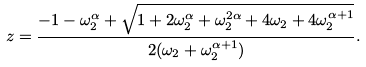Convert formula to latex. <formula><loc_0><loc_0><loc_500><loc_500>z = \frac { - 1 - \omega _ { 2 } ^ { \alpha } + \sqrt { 1 + 2 \omega _ { 2 } ^ { \alpha } + \omega _ { 2 } ^ { 2 \alpha } + 4 \omega _ { 2 } + 4 \omega _ { 2 } ^ { \alpha + 1 } } } { 2 ( \omega _ { 2 } + \omega _ { 2 } ^ { \alpha + 1 } ) } .</formula> 